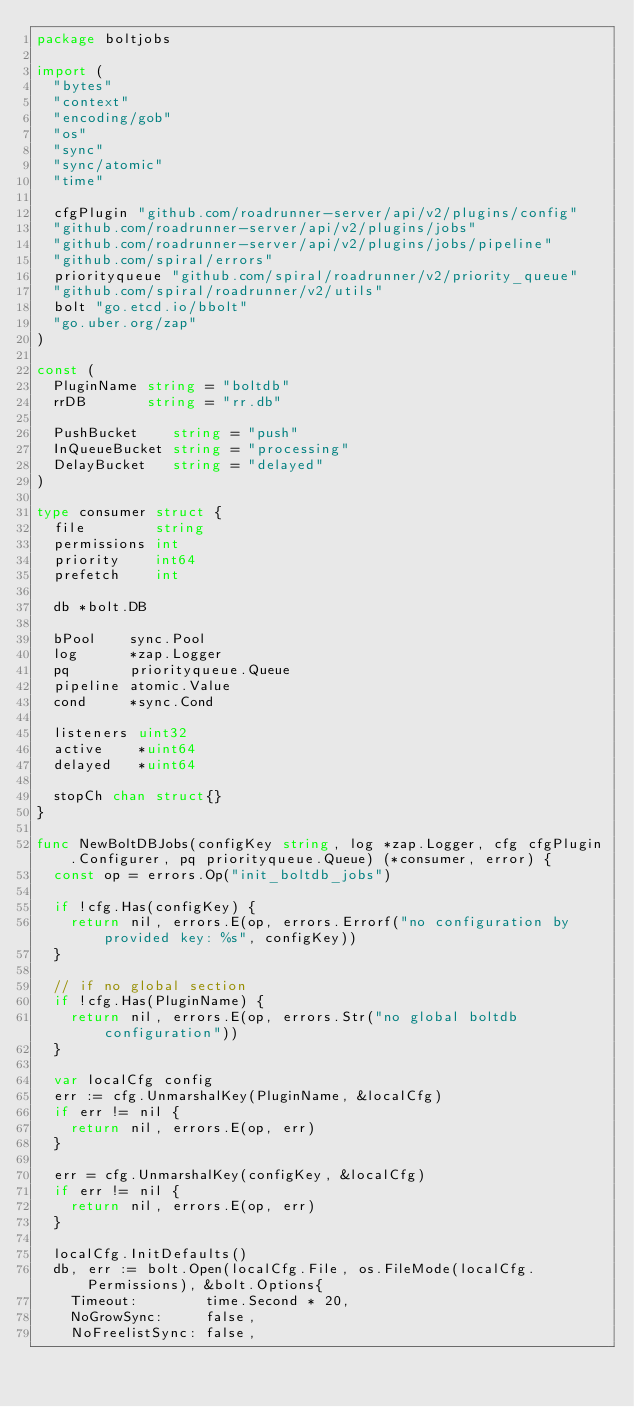<code> <loc_0><loc_0><loc_500><loc_500><_Go_>package boltjobs

import (
	"bytes"
	"context"
	"encoding/gob"
	"os"
	"sync"
	"sync/atomic"
	"time"

	cfgPlugin "github.com/roadrunner-server/api/v2/plugins/config"
	"github.com/roadrunner-server/api/v2/plugins/jobs"
	"github.com/roadrunner-server/api/v2/plugins/jobs/pipeline"
	"github.com/spiral/errors"
	priorityqueue "github.com/spiral/roadrunner/v2/priority_queue"
	"github.com/spiral/roadrunner/v2/utils"
	bolt "go.etcd.io/bbolt"
	"go.uber.org/zap"
)

const (
	PluginName string = "boltdb"
	rrDB       string = "rr.db"

	PushBucket    string = "push"
	InQueueBucket string = "processing"
	DelayBucket   string = "delayed"
)

type consumer struct {
	file        string
	permissions int
	priority    int64
	prefetch    int

	db *bolt.DB

	bPool    sync.Pool
	log      *zap.Logger
	pq       priorityqueue.Queue
	pipeline atomic.Value
	cond     *sync.Cond

	listeners uint32
	active    *uint64
	delayed   *uint64

	stopCh chan struct{}
}

func NewBoltDBJobs(configKey string, log *zap.Logger, cfg cfgPlugin.Configurer, pq priorityqueue.Queue) (*consumer, error) {
	const op = errors.Op("init_boltdb_jobs")

	if !cfg.Has(configKey) {
		return nil, errors.E(op, errors.Errorf("no configuration by provided key: %s", configKey))
	}

	// if no global section
	if !cfg.Has(PluginName) {
		return nil, errors.E(op, errors.Str("no global boltdb configuration"))
	}

	var localCfg config
	err := cfg.UnmarshalKey(PluginName, &localCfg)
	if err != nil {
		return nil, errors.E(op, err)
	}

	err = cfg.UnmarshalKey(configKey, &localCfg)
	if err != nil {
		return nil, errors.E(op, err)
	}

	localCfg.InitDefaults()
	db, err := bolt.Open(localCfg.File, os.FileMode(localCfg.Permissions), &bolt.Options{
		Timeout:        time.Second * 20,
		NoGrowSync:     false,
		NoFreelistSync: false,</code> 